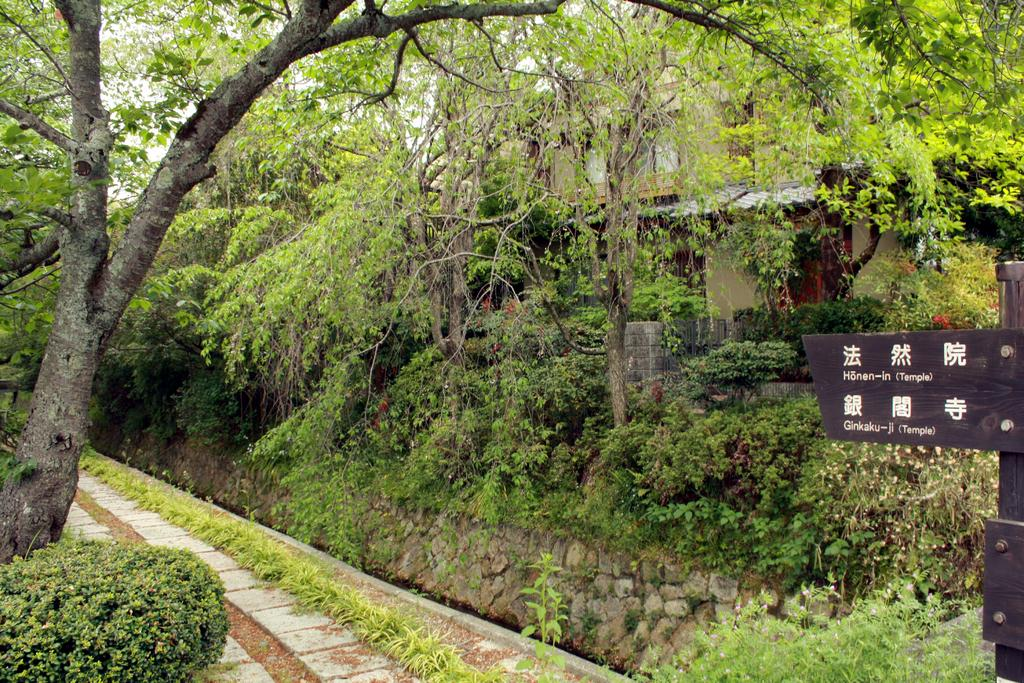What type of structure is visible in the image? There is a building in the image. What natural elements can be seen in the image? There are trees in the image. Where is the signboard located in the image? The signboard is on the right side of the image. What type of barrier is present in the image? There is a wall in the image. What type of surface is visible in the image? There is a path in the image. Can you tell me how many ears of corn are growing on the trees in the image? There are no ears of corn present on the trees in the image, as it features a building, trees, a signboard, a wall, and a path. 